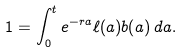Convert formula to latex. <formula><loc_0><loc_0><loc_500><loc_500>1 = \int _ { 0 } ^ { t } e ^ { - r a } \ell ( a ) b ( a ) \, d a .</formula> 